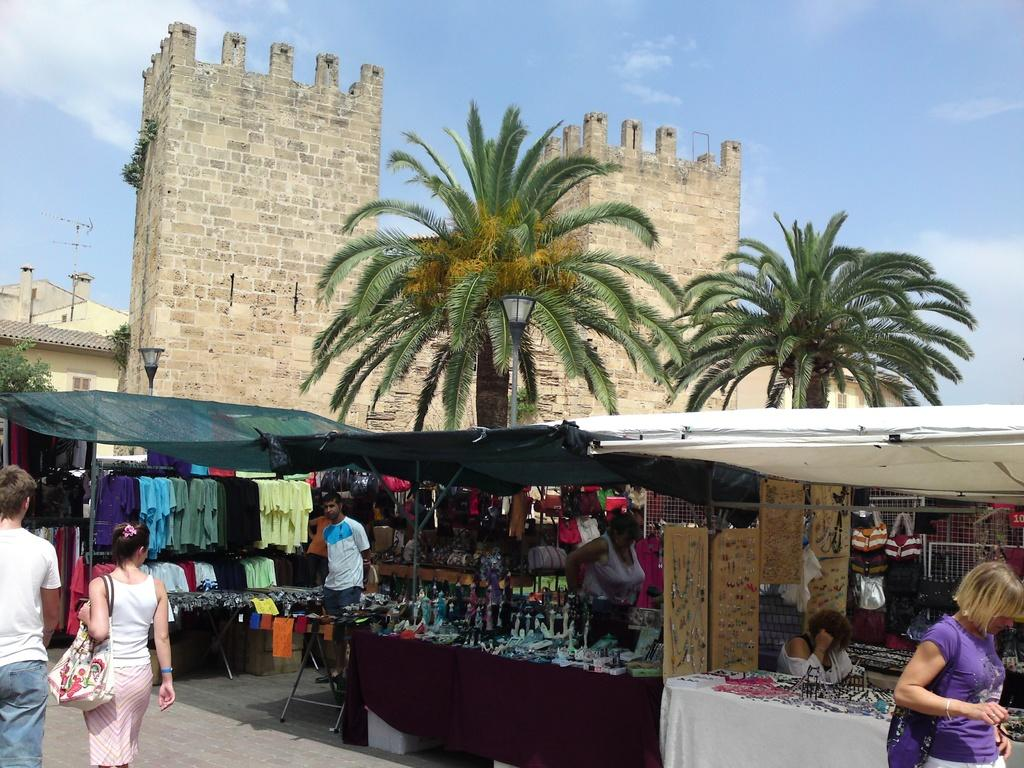What type of structures can be seen in the image? There are buildings in the image. What are the vertical objects on the sides of the road? Street poles are present in the image. What illuminates the road at night? Street lights are visible in the image. What type of vegetation is present in the image? Trees are in the image. What type of temporary shops can be seen in the image? Stalls are present in the image. What are the people in the image doing? There are persons standing on the road in the image. What can be seen in the sky in the image? The sky is visible in the image, and clouds are present in the sky. What type of chain is being used to hold the car in the image? There is no car present in the image, so there is no chain being used to hold it. 